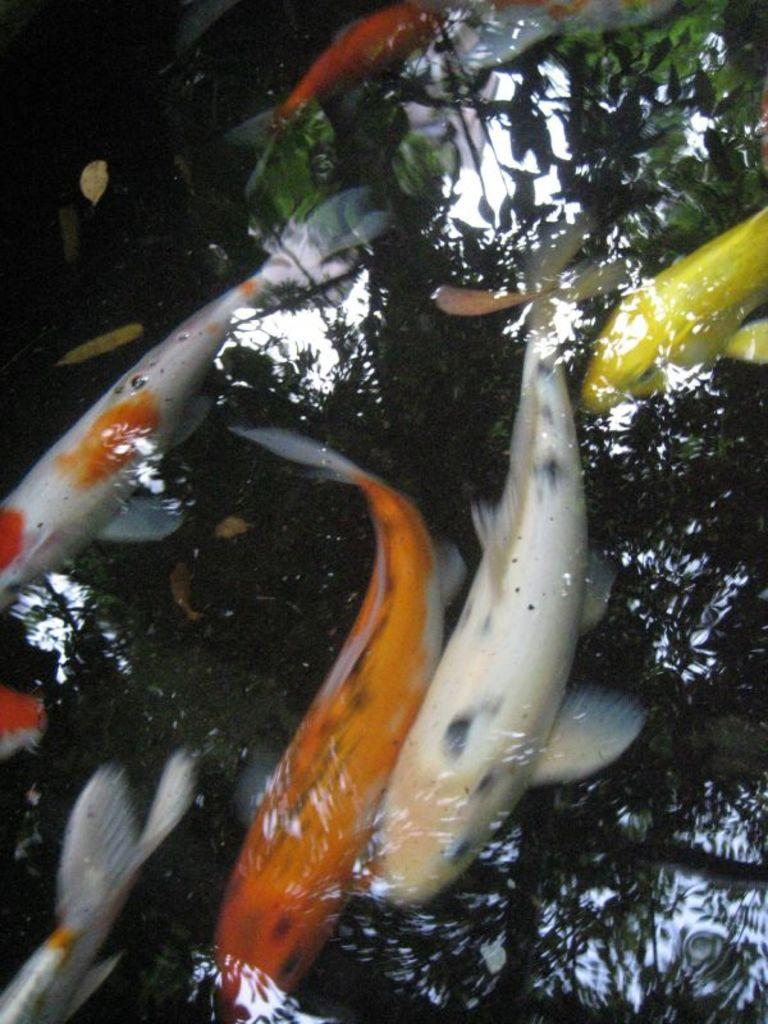What type of animals can be seen in the image? There are fishes in the image. What colors are the fishes in the image? The fishes are in orange, white, and yellow colors. What else is present in the water in the image? There are leaves in the water in the image. What is the primary element visible in the image? There is water visible in the image. What type of bag can be seen in the image? There is no bag present in the image; it features fishes in water with leaves. 